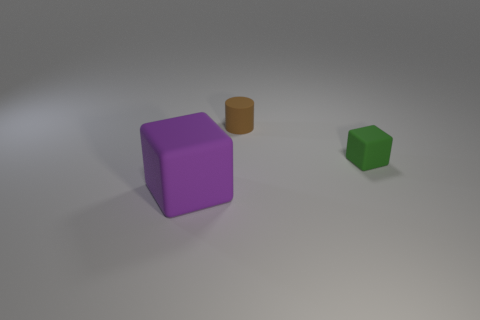Could you describe the texture of the objects? The objects seem to have a smooth texture with a matte finish, rather than a glossy or reflective surface. This type of surface would diffuse light uniformly, resulting in the soft-edged shadows we can observe in the image. 